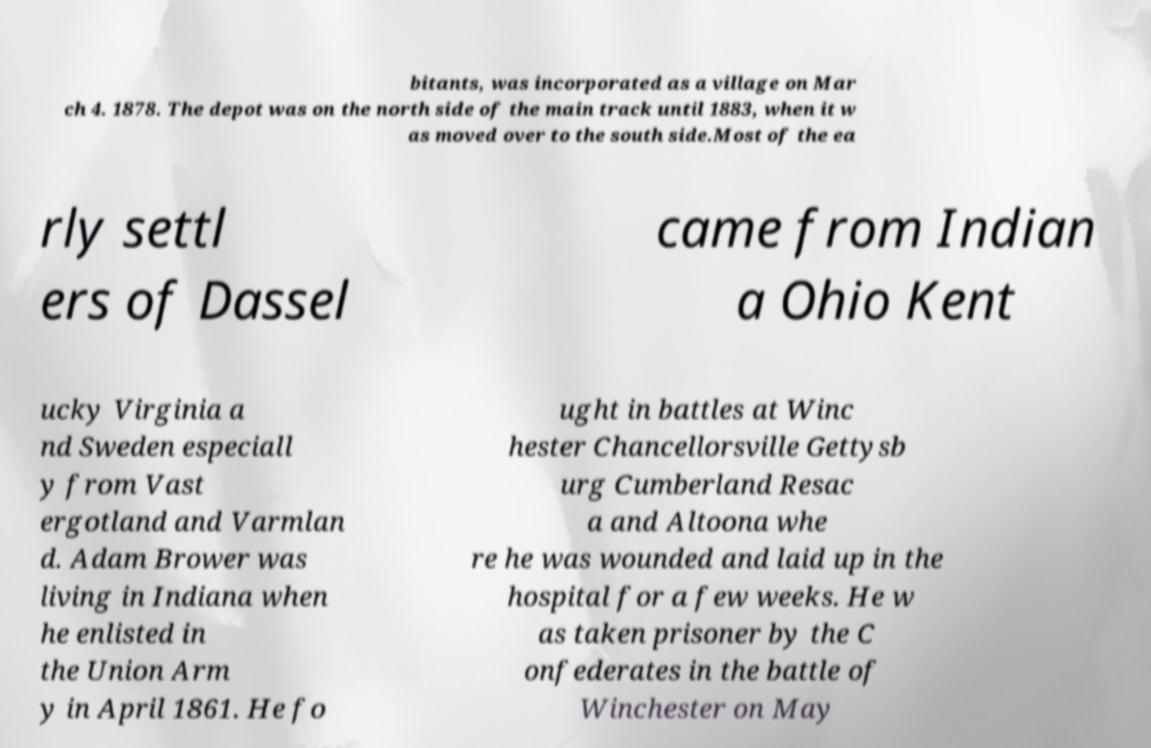I need the written content from this picture converted into text. Can you do that? bitants, was incorporated as a village on Mar ch 4. 1878. The depot was on the north side of the main track until 1883, when it w as moved over to the south side.Most of the ea rly settl ers of Dassel came from Indian a Ohio Kent ucky Virginia a nd Sweden especiall y from Vast ergotland and Varmlan d. Adam Brower was living in Indiana when he enlisted in the Union Arm y in April 1861. He fo ught in battles at Winc hester Chancellorsville Gettysb urg Cumberland Resac a and Altoona whe re he was wounded and laid up in the hospital for a few weeks. He w as taken prisoner by the C onfederates in the battle of Winchester on May 